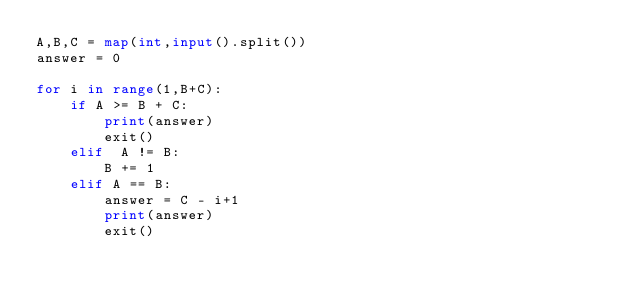<code> <loc_0><loc_0><loc_500><loc_500><_Python_>A,B,C = map(int,input().split())
answer = 0

for i in range(1,B+C):
    if A >= B + C:
        print(answer)
        exit()
    elif  A != B:
        B += 1
    elif A == B:
        answer = C - i+1
        print(answer)
        exit()</code> 